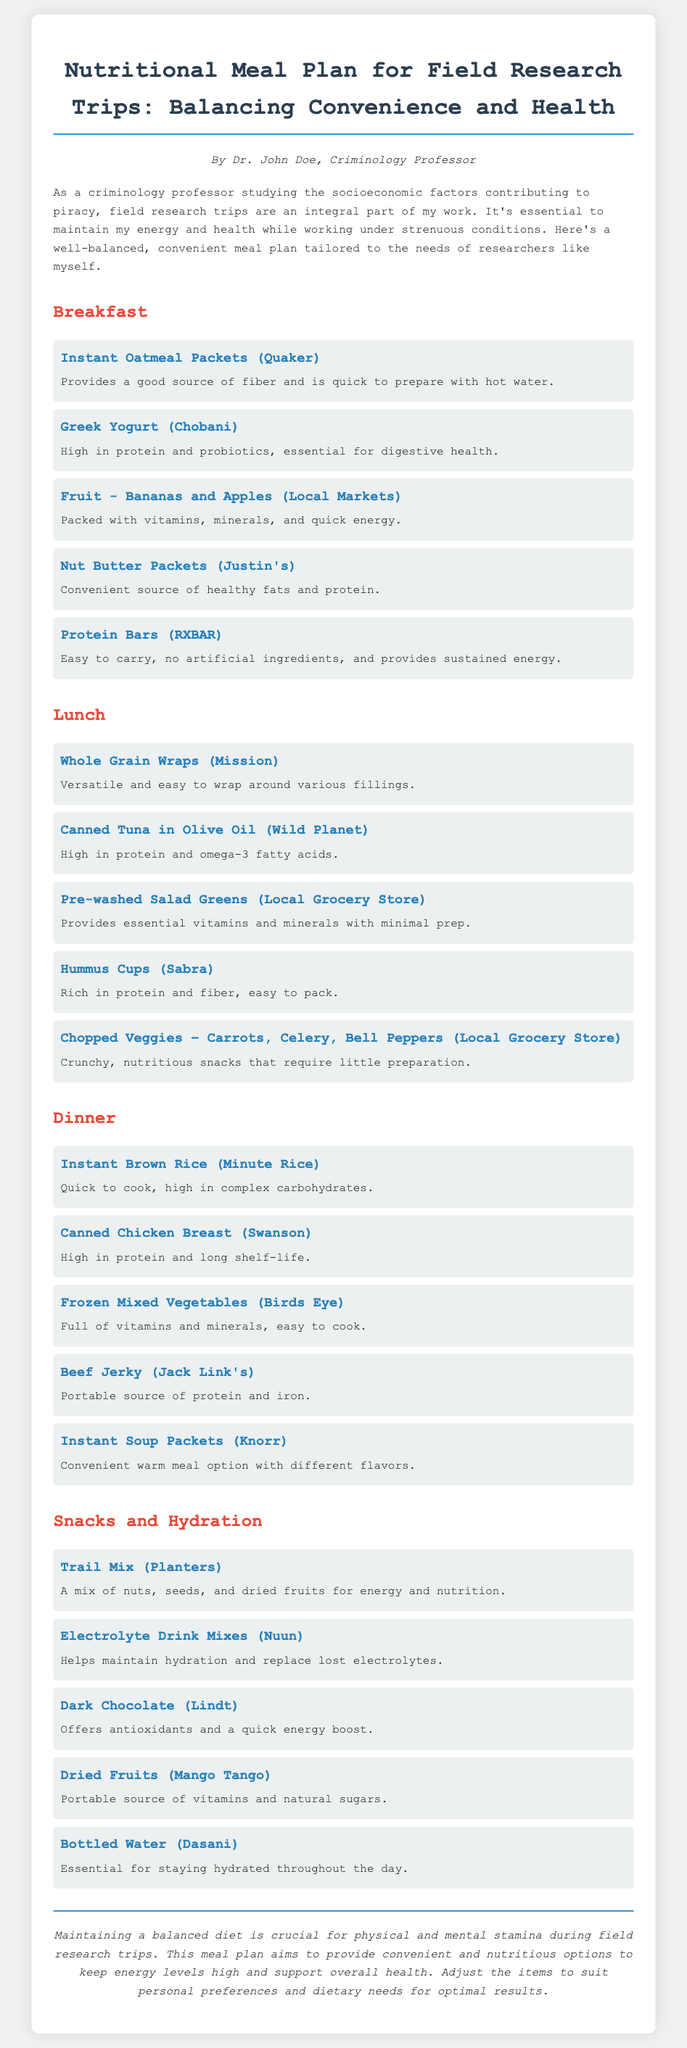What is the author's name? The author's name is mentioned at the beginning of the document as Dr. John Doe.
Answer: Dr. John Doe How many sections are there in the meal plan? The meal plan is divided into four sections: Breakfast, Lunch, Dinner, and Snacks and Hydration.
Answer: Four Which brand is associated with nut butter packets? The brand linked to nut butter packets in the breakfast section is Justin's.
Answer: Justin's What is a good source of electrolytes mentioned in the document? The document specifies electrolyte drink mixes from Nuun as a source of electrolytes.
Answer: Nuun What type of food is categorized under Snacks and Hydration? The document lists trail mix, a category of snacks, under Snacks and Hydration.
Answer: Trail Mix Which item in the lunch section is easy to pack? The hummus cups from Sabra are noted as rich in protein and easy to pack.
Answer: Hummus Cups What is a portable source of vitamins mentioned in the snacks section? Dried fruits are highlighted as a portable source of vitamins in the snacks section.
Answer: Dried Fruits What type of carbohydrate is the instant brown rice high in? Instant brown rice is specified to be high in complex carbohydrates.
Answer: Complex carbohydrates Which meal option is described as providing sustained energy? Protein bars from RXBAR are described to provide sustained energy in the breakfast section.
Answer: Protein Bars 